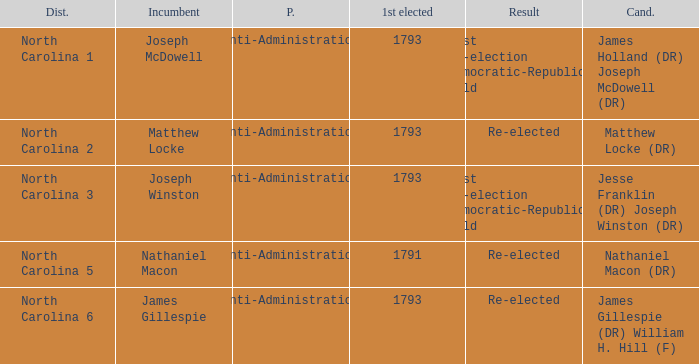Who was the candidate in 1791? Nathaniel Macon (DR). 